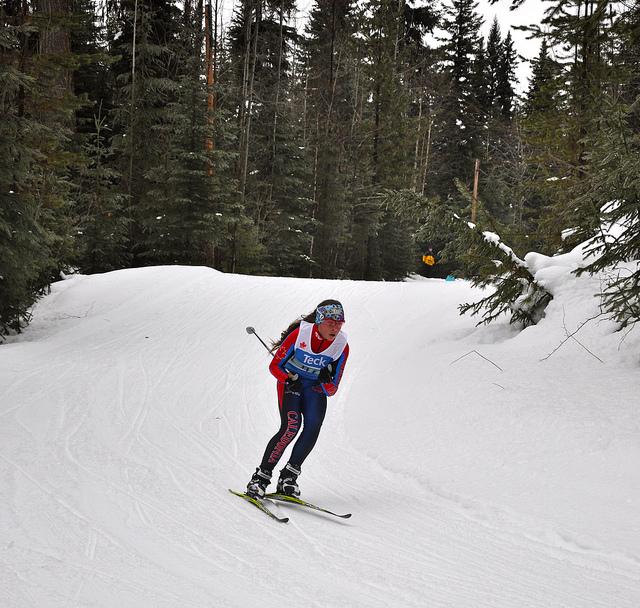What season is this?
Keep it brief. Winter. Is she in the forest?
Be succinct. Yes. What is the woman holding?
Be succinct. Ski poles. Is it winter?
Concise answer only. Yes. 